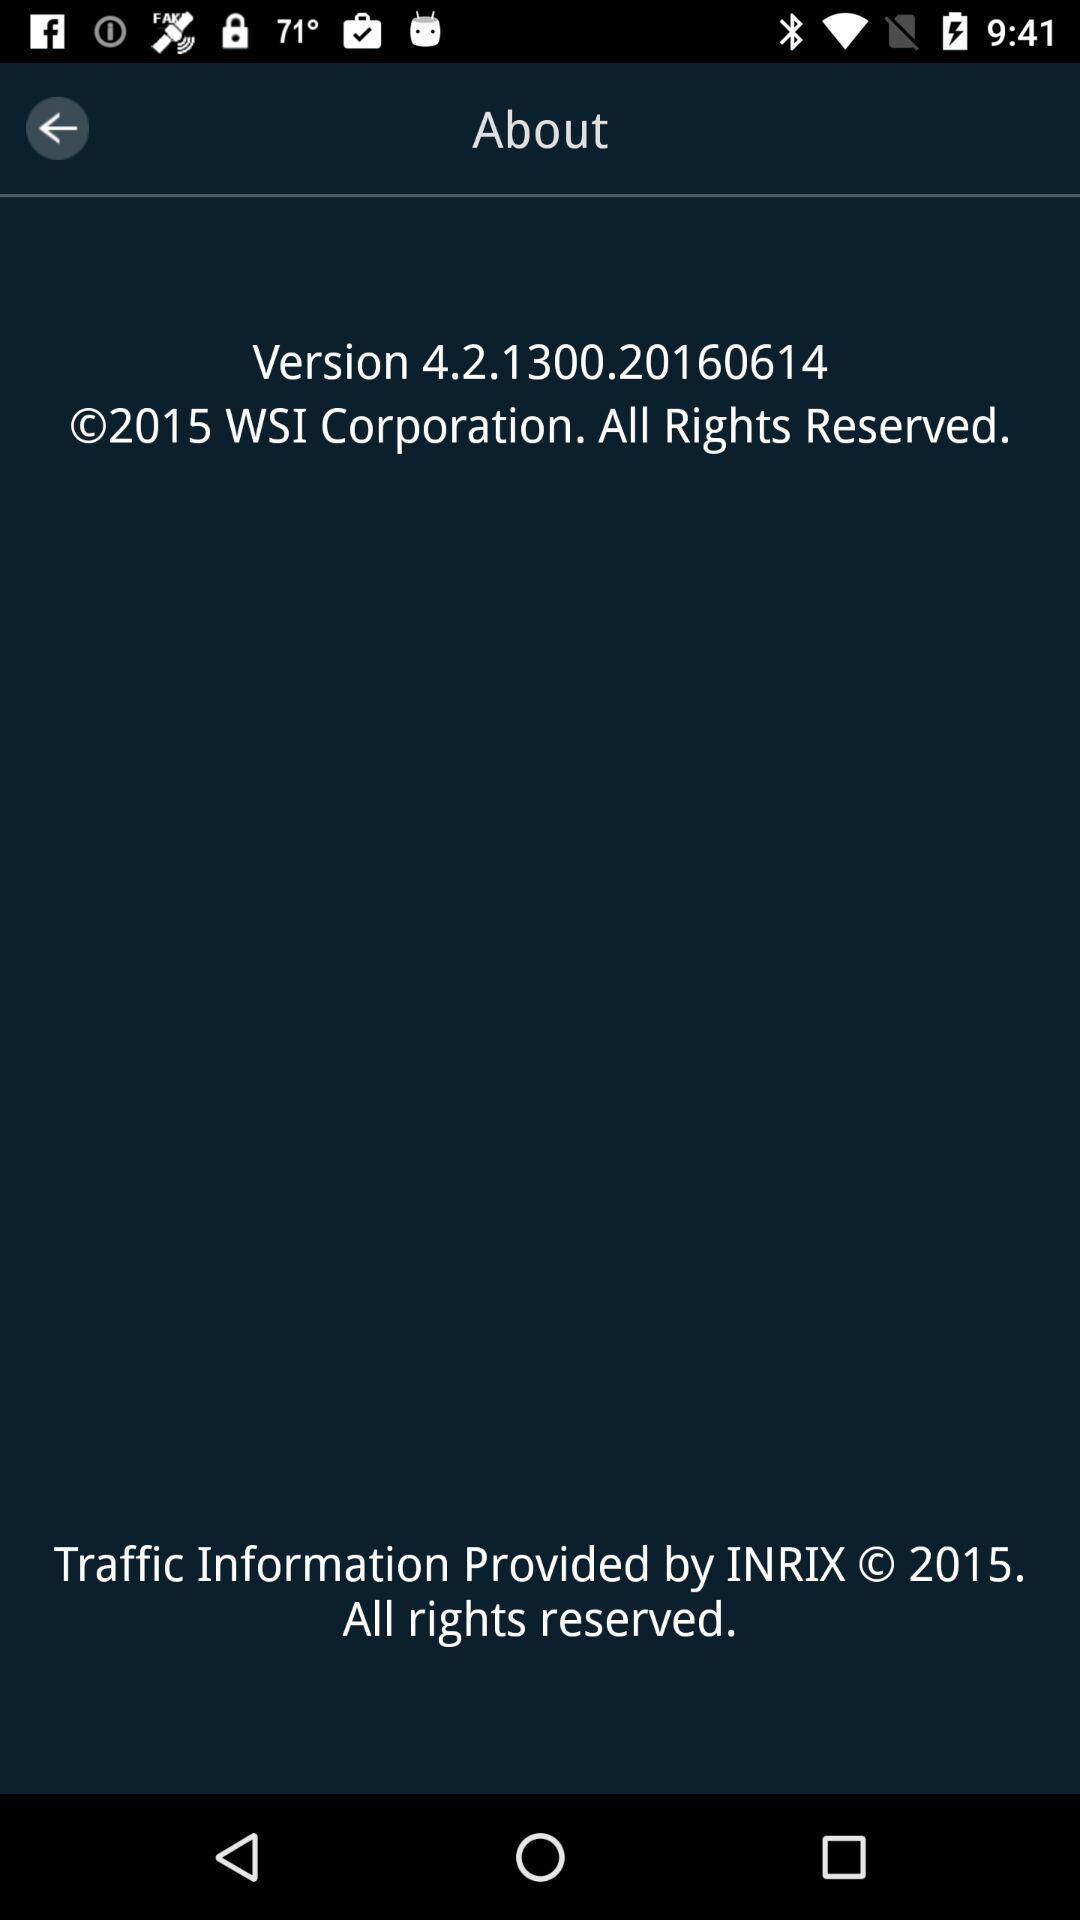How many lines of text are there in the bottom section of the screen?
Answer the question using a single word or phrase. 2 